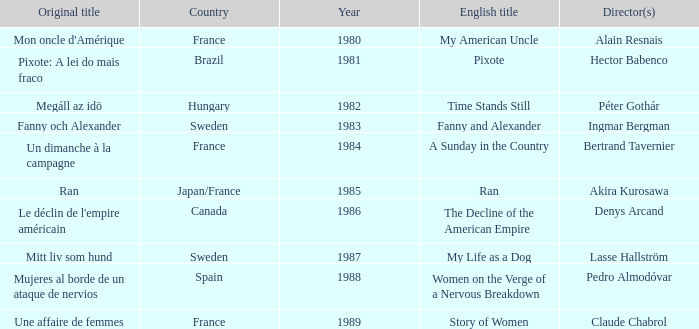What's the English Title of Fanny Och Alexander? Fanny and Alexander. 